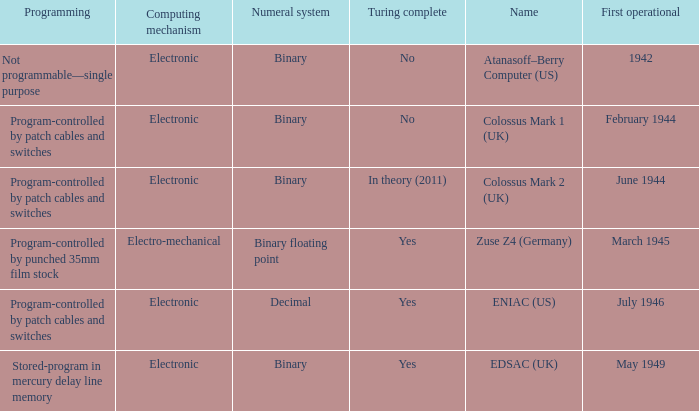What's the name with first operational being march 1945 Zuse Z4 (Germany). 